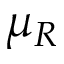<formula> <loc_0><loc_0><loc_500><loc_500>\mu _ { R }</formula> 